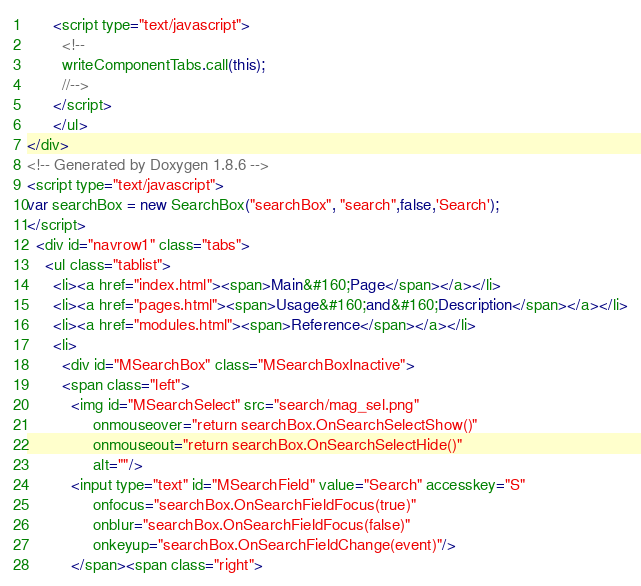Convert code to text. <code><loc_0><loc_0><loc_500><loc_500><_HTML_>      <script type="text/javascript">
		<!--
		writeComponentTabs.call(this);
		//-->
      </script>
	  </ul>
</div>
<!-- Generated by Doxygen 1.8.6 -->
<script type="text/javascript">
var searchBox = new SearchBox("searchBox", "search",false,'Search');
</script>
  <div id="navrow1" class="tabs">
    <ul class="tablist">
      <li><a href="index.html"><span>Main&#160;Page</span></a></li>
      <li><a href="pages.html"><span>Usage&#160;and&#160;Description</span></a></li>
      <li><a href="modules.html"><span>Reference</span></a></li>
      <li>
        <div id="MSearchBox" class="MSearchBoxInactive">
        <span class="left">
          <img id="MSearchSelect" src="search/mag_sel.png"
               onmouseover="return searchBox.OnSearchSelectShow()"
               onmouseout="return searchBox.OnSearchSelectHide()"
               alt=""/>
          <input type="text" id="MSearchField" value="Search" accesskey="S"
               onfocus="searchBox.OnSearchFieldFocus(true)" 
               onblur="searchBox.OnSearchFieldFocus(false)" 
               onkeyup="searchBox.OnSearchFieldChange(event)"/>
          </span><span class="right"></code> 